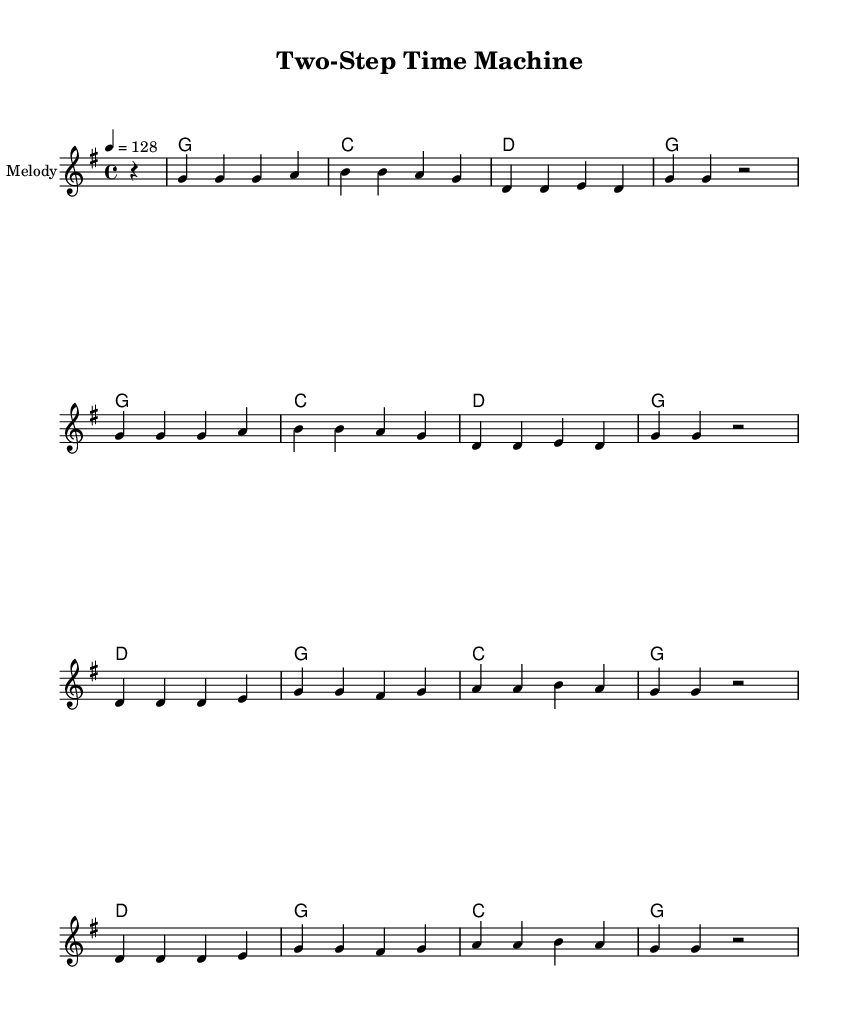What is the key signature of this music? The key signature is G major, which has one sharp (F#). The symbol for the sharp is present on the staff adjacent to the G scale notes.
Answer: G major What is the time signature of the piece? The time signature shown at the beginning is 4/4, indicating four beats per measure. This is denoted in the top left corner of the sheet music.
Answer: 4/4 What is the tempo marking? The tempo marking indicates a speed of 128 beats per minute, noted as "4 = 128" in the tempo text. This shows how fast the piece should be played.
Answer: 128 Which chord is played at the beginning? The first chord shown in the harmonies is G major, represented at the start of the chord line as the first symbol.
Answer: G How many measures are in the chorus? The chorus consists of four measures, which can be counted by identifying the measures separated by vertical lines throughout the lyric section labeled "chorus."
Answer: 4 What type of dance is this song likely associated with? This song is associated with line dancing, which is highlighted in the lyrics and the upbeat style typical of country rock, inviting listeners to move together as a group.
Answer: Line dancing What is the main theme expressed in the lyrics? The main theme of the lyrics emphasizes nostalgia and celebration of dance, as depicted in lines about traveling back in style to dance. This reflects the joy and social aspect of line dancing for seniors.
Answer: Nostalgia 